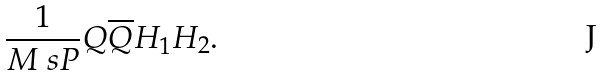Convert formula to latex. <formula><loc_0><loc_0><loc_500><loc_500>\frac { 1 } { M _ { \ } s { P } } Q \overline { Q } H _ { 1 } H _ { 2 } .</formula> 